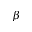<formula> <loc_0><loc_0><loc_500><loc_500>\beta</formula> 